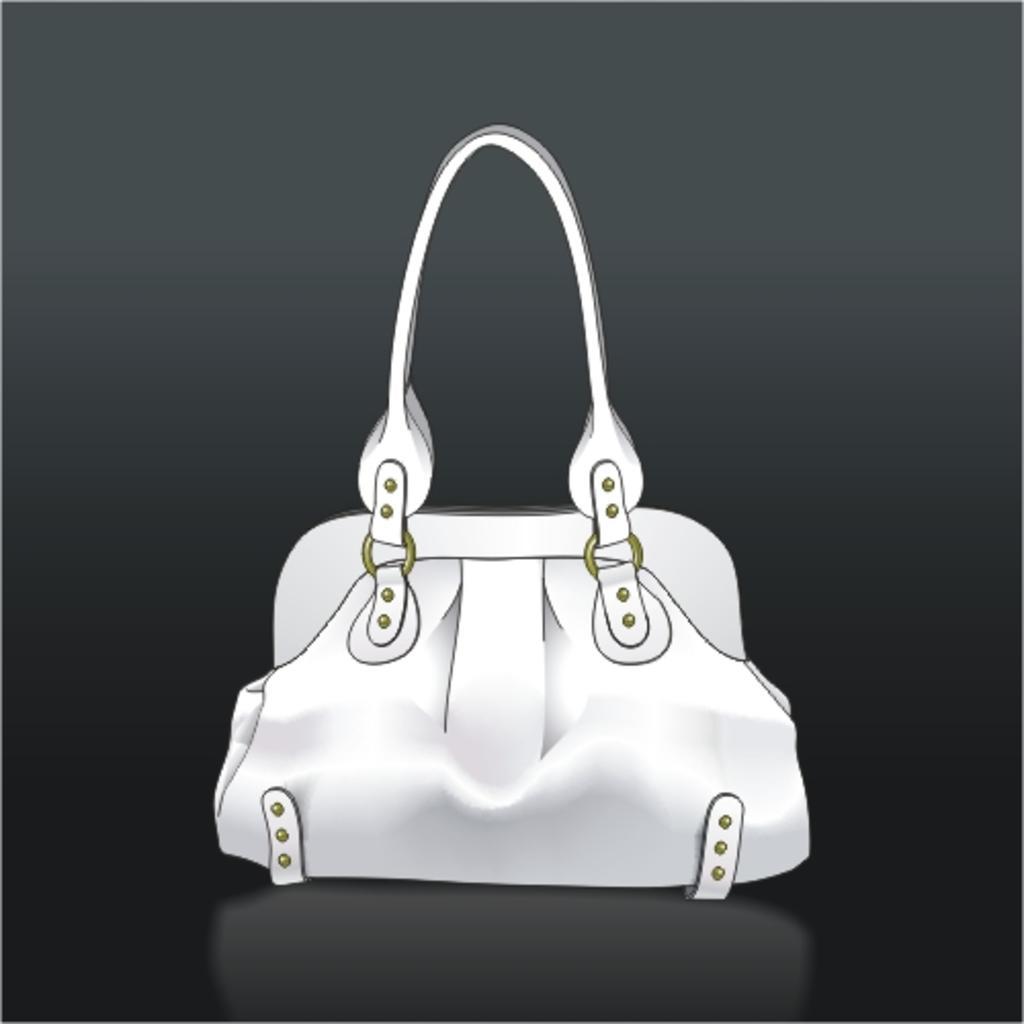Please provide a concise description of this image. There is a bag. The bag has a belt in it. 